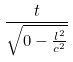Convert formula to latex. <formula><loc_0><loc_0><loc_500><loc_500>\frac { t } { \sqrt { 0 - \frac { l ^ { 2 } } { c ^ { 2 } } } }</formula> 